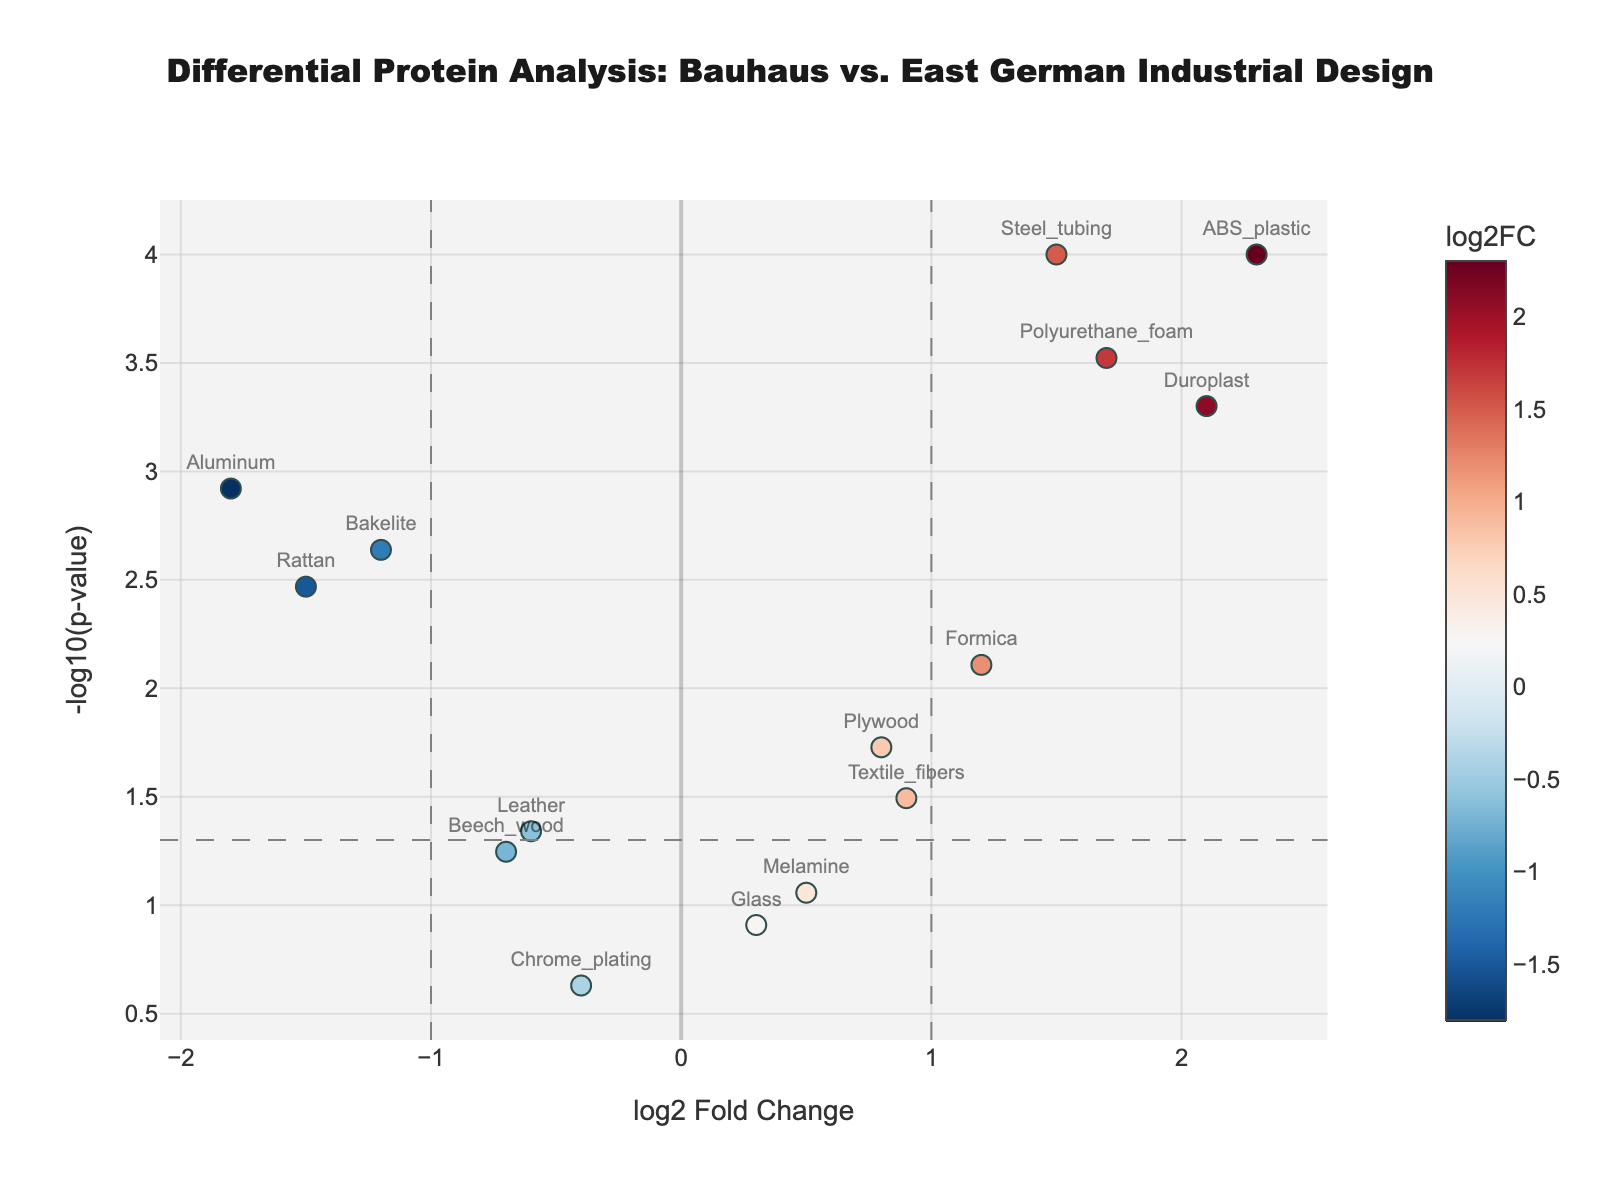What is the title of the figure? The title of the figure is usually located at the top and clearly states the context of the data visualization. In this case, it says "Differential Protein Analysis: Bauhaus vs. East German Industrial Design."
Answer: Differential Protein Analysis: Bauhaus vs. East German Industrial Design How many meaningful data points have p-values below 0.05? To determine this, we look for points above the horizontal dashed line (representing -log10(0.05)), which signifies significant p-values. Counting these points, we find there are 11 significant data points.
Answer: 11 Which material has the highest log2 Fold Change (log2FC) value? To find this, we identify the highest point on the x-axis. The materials are labeled, and ABS_plastic corresponds to the highest log2FC at 2.3.
Answer: ABS_plastic What is the color scheme used to indicate log2FC values? The figure uses a color gradient to represent log2FC values. The color bar next to the plot indicates the scale, which ranges through shades of red and blue. Red corresponds to negative log2FC and blue to positive log2FC.
Answer: Red to blue gradient Which material is the most statistically significant, and how do you determine this? To identify the most statistically significant material, we look for the highest point on the y-axis (-log10(p-value)). ABS_plastic is the highest with a p-value of 0.0001.
Answer: ABS_plastic Which two materials have log2FC values of approximately 1.5 and -1.5, and how do their p-values compare? The materials with log2FC values near 1.5 and -1.5 are Steel_tubing and Rattan. Steel_tubing has a lower p-value (higher -log10(p)) compared to Rattan, making it more statistically significant.
Answer: Steel_tubing and Rattan; Steel_tubing has a lower p-value How does the significance of Polyurethane_foam compare to that of Bakelite? Look at the -log10(p-value) for both materials. Polyurethane_foam has a higher -log10(p) than Bakelite, indicating a more significant p-value.
Answer: Polyurethane_foam is more significant Which material has the smallest absolute log2FC value, and is it statistically significant? The smallest absolute log2FC is for Glass (log2FC=0.3). Its p-value is above 0.05, meaning it is not statistically significant.
Answer: Glass; No List all materials with a statistically significant negative log2FC. For statistically significant negative log2FC, locate points left of the vertical dashed line -1 with p-values below 0.05. Materials are Bakelite, Aluminum, and Rattan.
Answer: Bakelite, Aluminum, and Rattan 